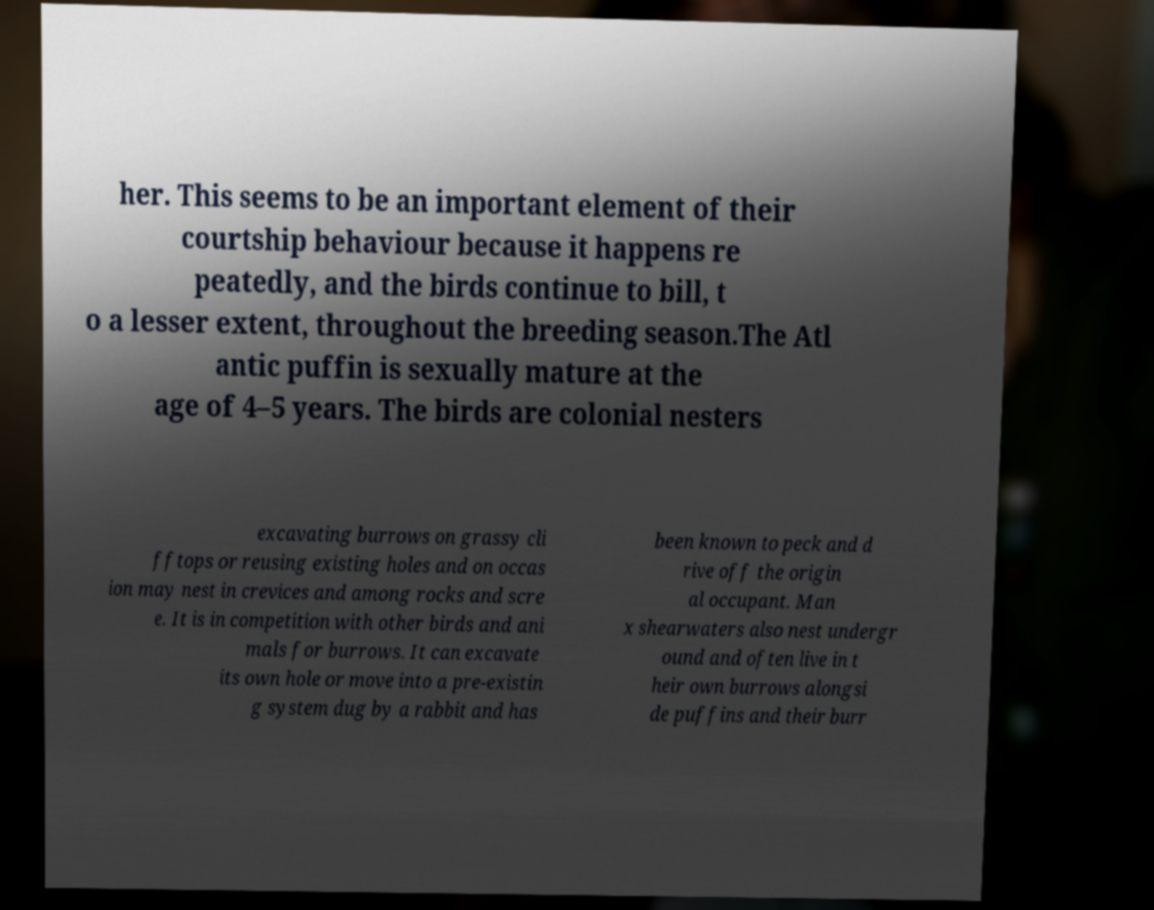Could you assist in decoding the text presented in this image and type it out clearly? her. This seems to be an important element of their courtship behaviour because it happens re peatedly, and the birds continue to bill, t o a lesser extent, throughout the breeding season.The Atl antic puffin is sexually mature at the age of 4–5 years. The birds are colonial nesters excavating burrows on grassy cli fftops or reusing existing holes and on occas ion may nest in crevices and among rocks and scre e. It is in competition with other birds and ani mals for burrows. It can excavate its own hole or move into a pre-existin g system dug by a rabbit and has been known to peck and d rive off the origin al occupant. Man x shearwaters also nest undergr ound and often live in t heir own burrows alongsi de puffins and their burr 